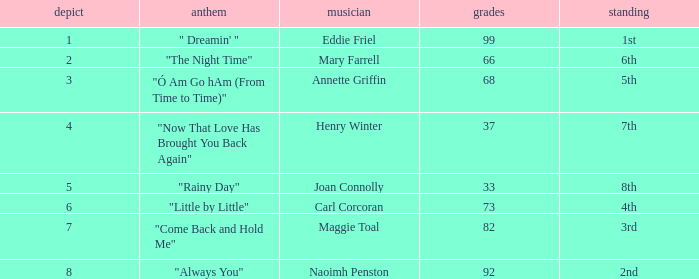What is the mean score for a 7th place ranking with a draw of fewer than 4 points? None. 